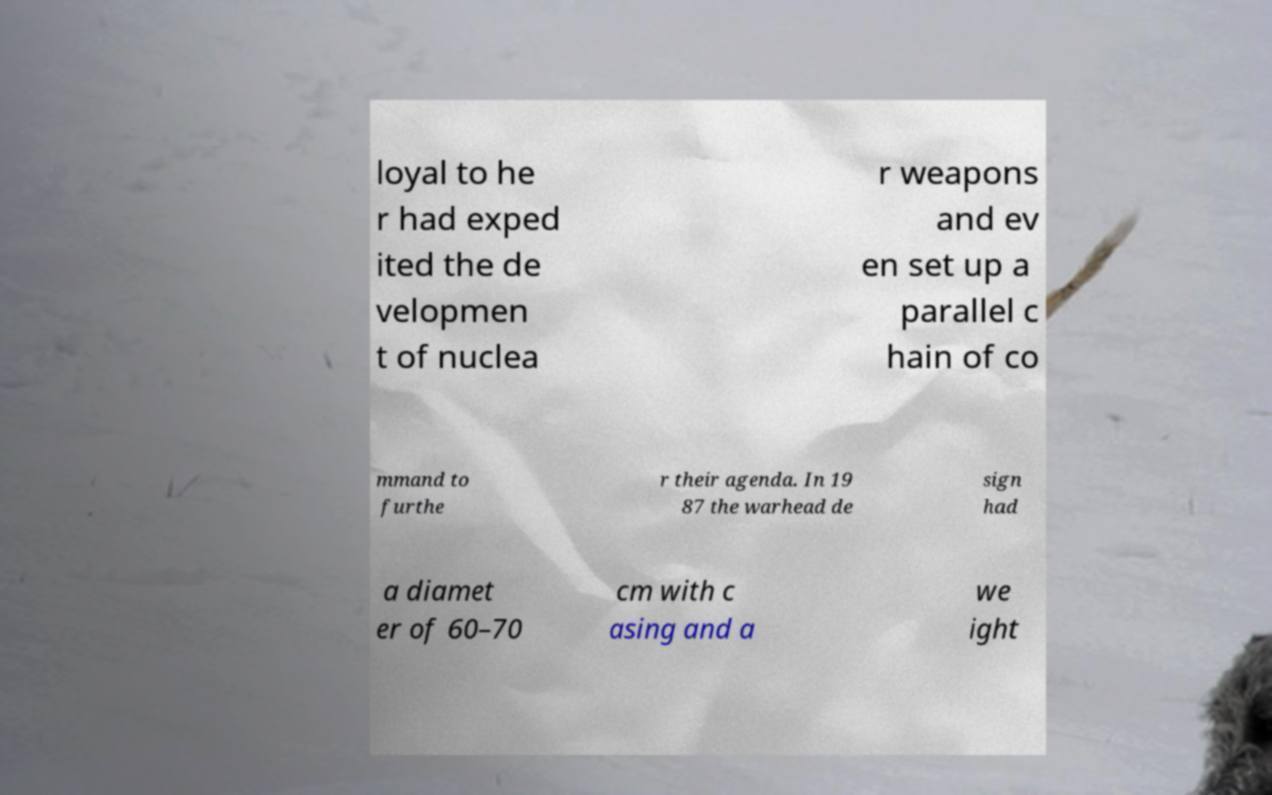Could you assist in decoding the text presented in this image and type it out clearly? loyal to he r had exped ited the de velopmen t of nuclea r weapons and ev en set up a parallel c hain of co mmand to furthe r their agenda. In 19 87 the warhead de sign had a diamet er of 60–70 cm with c asing and a we ight 